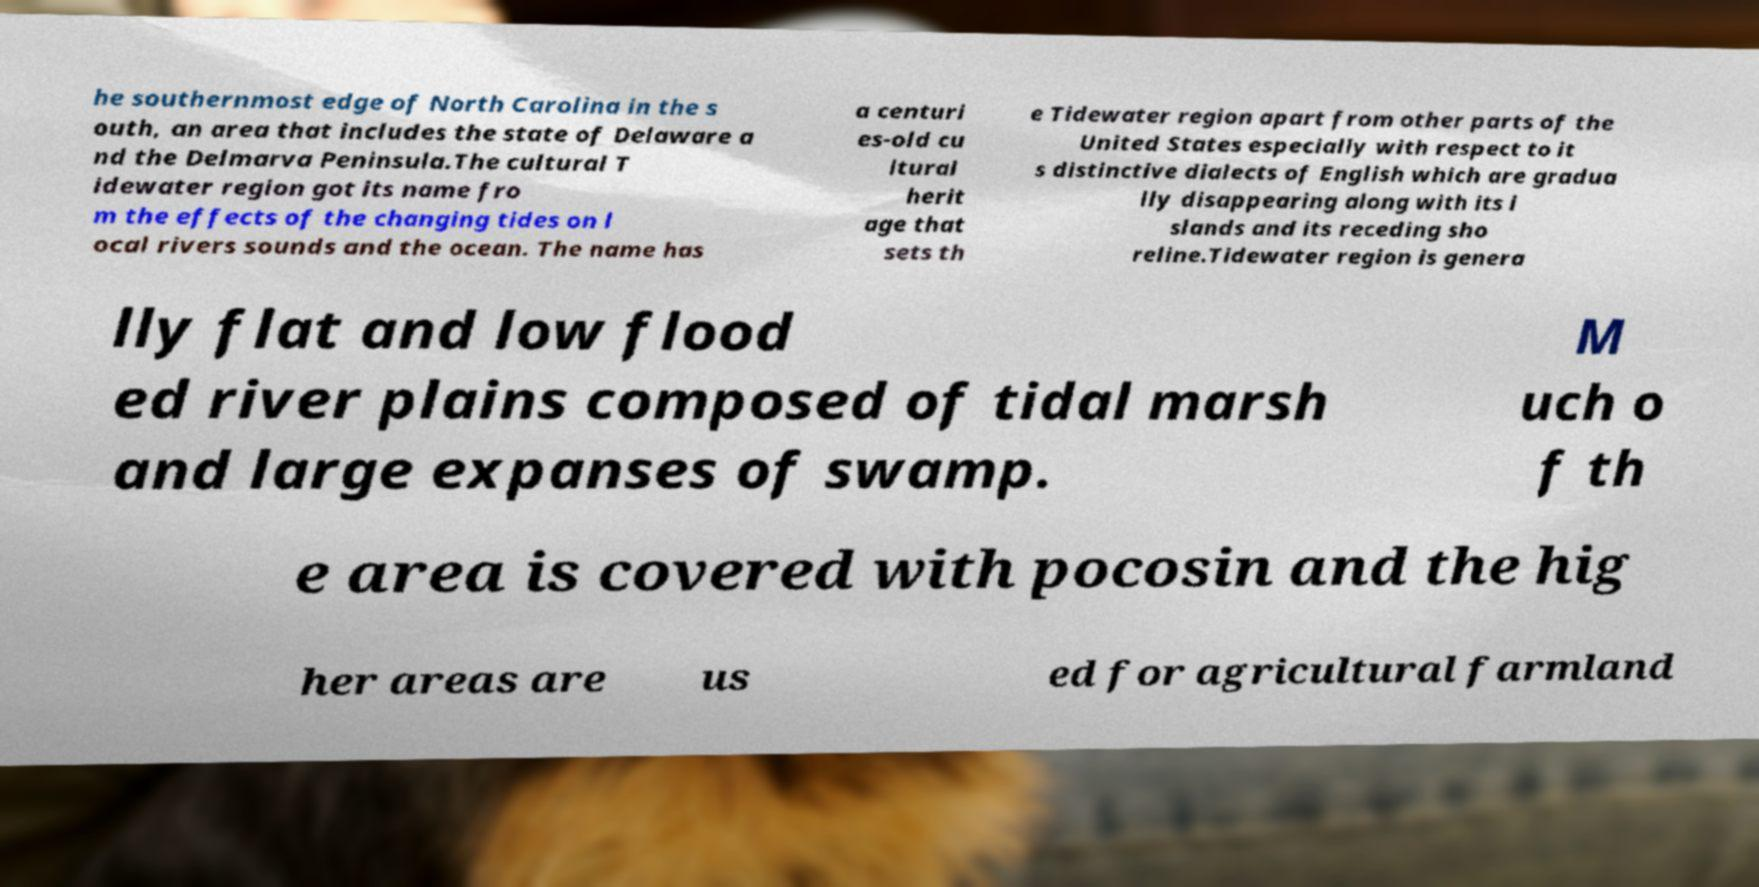For documentation purposes, I need the text within this image transcribed. Could you provide that? he southernmost edge of North Carolina in the s outh, an area that includes the state of Delaware a nd the Delmarva Peninsula.The cultural T idewater region got its name fro m the effects of the changing tides on l ocal rivers sounds and the ocean. The name has a centuri es-old cu ltural herit age that sets th e Tidewater region apart from other parts of the United States especially with respect to it s distinctive dialects of English which are gradua lly disappearing along with its i slands and its receding sho reline.Tidewater region is genera lly flat and low flood ed river plains composed of tidal marsh and large expanses of swamp. M uch o f th e area is covered with pocosin and the hig her areas are us ed for agricultural farmland 